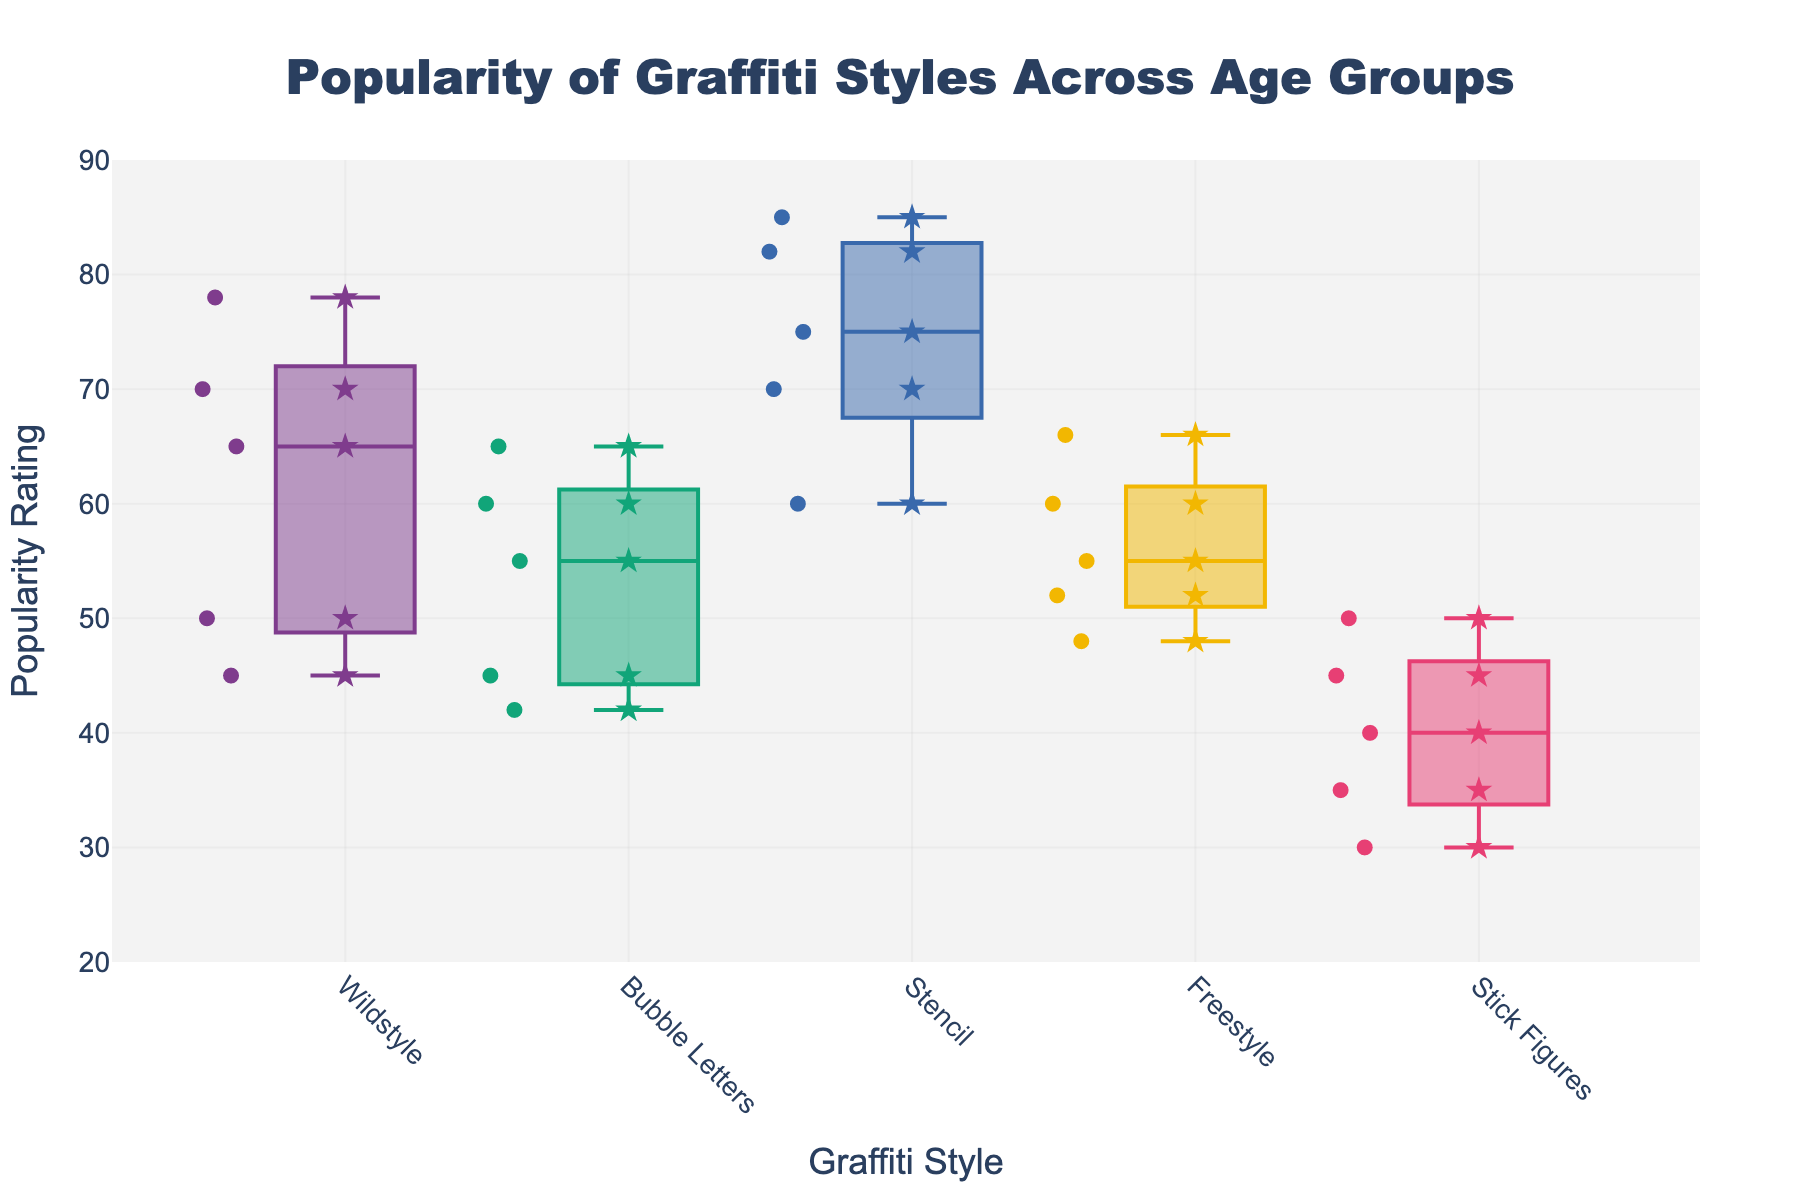What's the title of the figure? The title of the figure is usually placed at the top center. In this plot, the title is written as 'Popularity of Graffiti Styles Across Age Groups' at the top.
Answer: Popularity of Graffiti Styles Across Age Groups What are the labels on the x-axis and y-axis? The x-axis typically represents the categories being compared, and the y-axis represents the corresponding values. Here, the x-axis is labeled 'Graffiti Style' and the y-axis is labeled 'Popularity Rating'.
Answer: Graffiti Style, Popularity Rating Which graffiti style has the highest median popularity rating? To determine the graffiti style with the highest median, look for the middle line in the box plots that is positioned highest on the y-axis. The 'Stencil' graffiti style appears to have the highest median.
Answer: Stencil Between the age group 18-25 and 56-65, which group prefers Wildstyle more? By examining the position of the scatter points and the distribution (box plot), we can compare the popularity ratings directly. The age group 18-25 has higher ratings around 78, compared to the age group 56-65 which has ratings around 45, indicating higher preference in 18-25.
Answer: 18-25 Which age group shows the most consistent preference for Bubble Letters graffiti style? Preference consistency can be measured by looking at the spread of the box plot. The narrower the box, the more consistent the preferences. The age group 56-65 shows the narrowest box plot for Bubble Letters, indicating the most consistent preference.
Answer: 56-65 What's the popularity rating range for Freestyle graffiti style across all age groups? The range is found by examining the lowest and highest points in the scatter plot for Freestyle. Freestyle has ratings from a low of 48 (56-65 age group) to a high of 66 (26-35 age group).
Answer: 48 to 66 Are there any outliers in the popularity ratings for Stick Figures? Outliers are represented by points outside the whiskers of the box plots. There are no points located outside the whiskers for Stick Figures across all age groups, indicating no outliers.
Answer: No Which graffiti style shows the largest difference in median popularity ratings between any two age groups? By comparing the medians (middle line in the box plots) of each graffiti style between age groups, 'Wildstyle' shows the largest median difference. The largest difference is between the age groups 18-25 and 56-65.
Answer: Wildstyle How do the popularity ratings for Stencil graffiti style across different age groups compare? The box plots and scatter points for Stencil show ratings: 82 (18-25), 85 (26-35), 75 (36-45), 70 (46-55), and 60 (56-65). The highest popularity is in the 26-35 age group and it gradually decreases with age.
Answer: Gradually decreases with age Would you say the preference for Stick Figures decreases with age? By analyzing the distribution and scatter points for Stick Figures, the ratings decrease as age increases, starting from 45 (18-25) to 30 (56-65). This shows a declining trend in preference with age.
Answer: Yes 